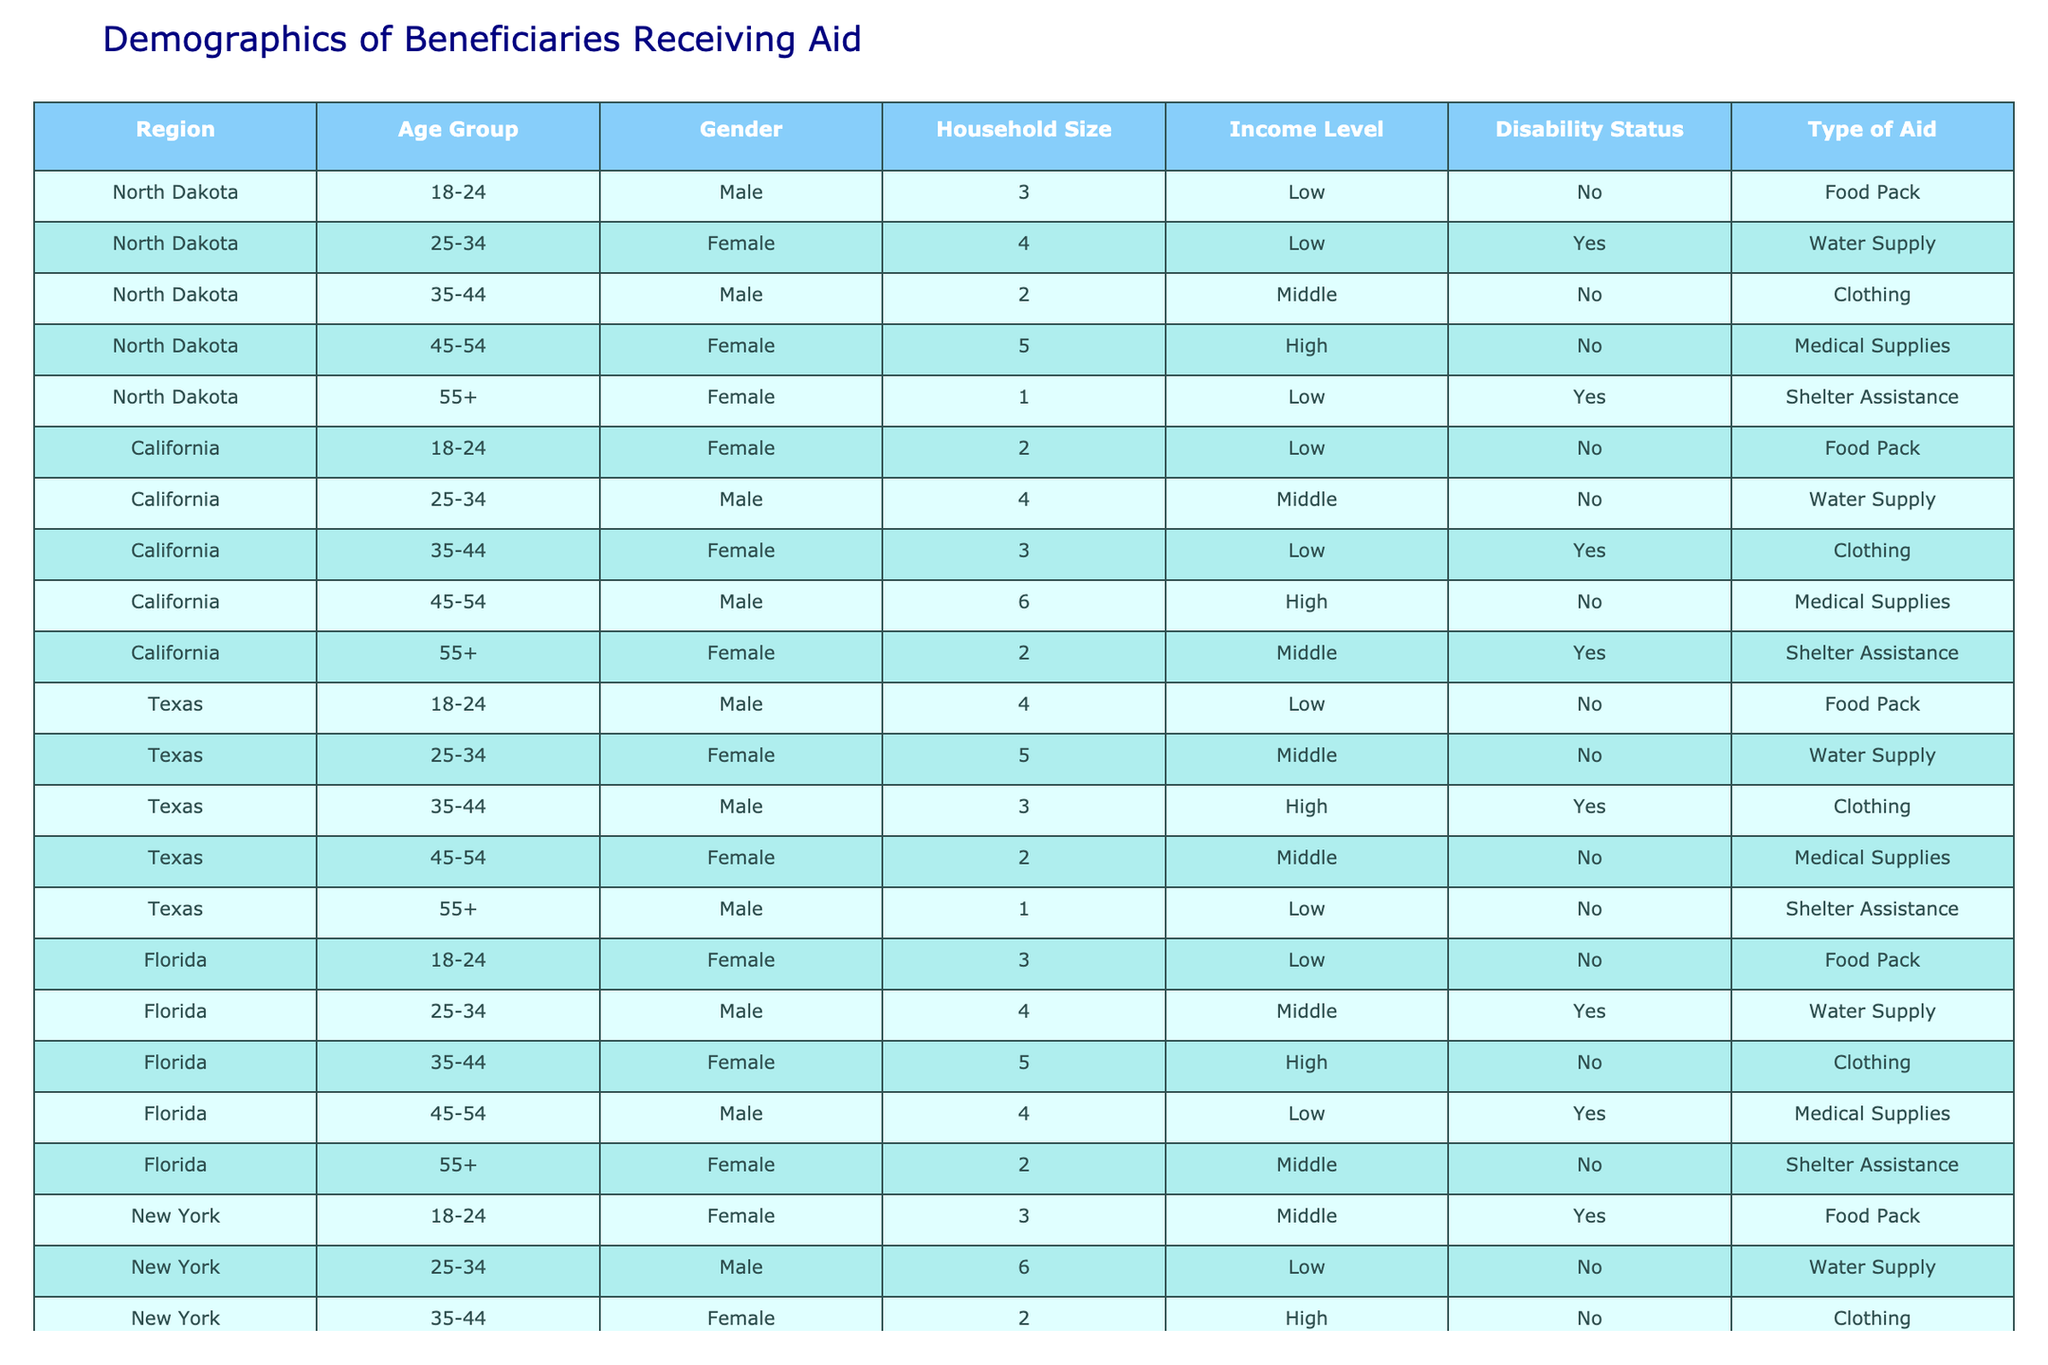What type of aid is most frequently given in North Dakota? In North Dakota, the table shows that three types of aid are distributed: Food Pack, Water Supply, Clothing, Medical Supplies, and Shelter Assistance. The most recurring type is Food Pack, which appears in one of the entries.
Answer: Food Pack How many total beneficiaries are there in California? By counting the entries for California in the table, there are a total of 5 beneficiaries recorded from this region.
Answer: 5 Which gender has received more aid in Texas? In Texas, we have equal entries for both males and females receiving aid (four males and four females). Hence, there is no gender that has received more aid than the other.
Answer: Neither What is the average household size of beneficiaries receiving aid in Florida? In Florida, the household sizes listed are 3, 4, 5, 4, and 2. Adding these gives a total of 18, and dividing by 5 gives an average household size of 18/5 = 3.6.
Answer: 3.6 Which region has the highest number of beneficiaries receiving medical supplies? Examining the entries, only North Dakota, California, Texas, and Florida have beneficiaries listed for medical supplies, each with one. Since there is one beneficiary per region for medical supplies, no region has a higher number for this type.
Answer: None Is there any beneficiary with a disability receiving food packs in the table? Checking the entries, in North Dakota and California, the food pack recipients do not have a disability, as indicated by their “No” status in the Disability column. Therefore, there are no beneficiaries with a disability receiving food packs.
Answer: No What is the total income level count for beneficiaries in New York? In New York, the income levels are Middle, Low, High, Low, and Middle. The unique counts are two Middle, two Low, and one High, totaling five beneficiaries, but they vary in income level.
Answer: 5 How many females received clothing aid across all regions? Males and females are checked for clothing aid in each region's entries. The entries show two females receiving clothing: one from California and one from Texas, leading to a total of two female beneficiaries receiving clothing aid.
Answer: 2 What percentage of beneficiaries with a disability received shelter assistance? Among those with a disability, there are two entries across all regions that have that status, and only one received shelter assistance in North Dakota; thus, the percentage is (1/2)*100 = 50%.
Answer: 50% Which age group has the highest representation among beneficiaries in all regions combined? By examining the age groups, 18-24 appears four times, 25-34 three times, 35-44 four times, 45-54 four times, and 55+ three times across all regions. Hence, 18-24 is the age group with the highest representation, alongside 35-44 and 45-54.
Answer: 18-24, 35-44, and 45-54 